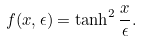Convert formula to latex. <formula><loc_0><loc_0><loc_500><loc_500>f ( x , \epsilon ) = \tanh ^ { 2 } { \frac { x } { \epsilon } } .</formula> 